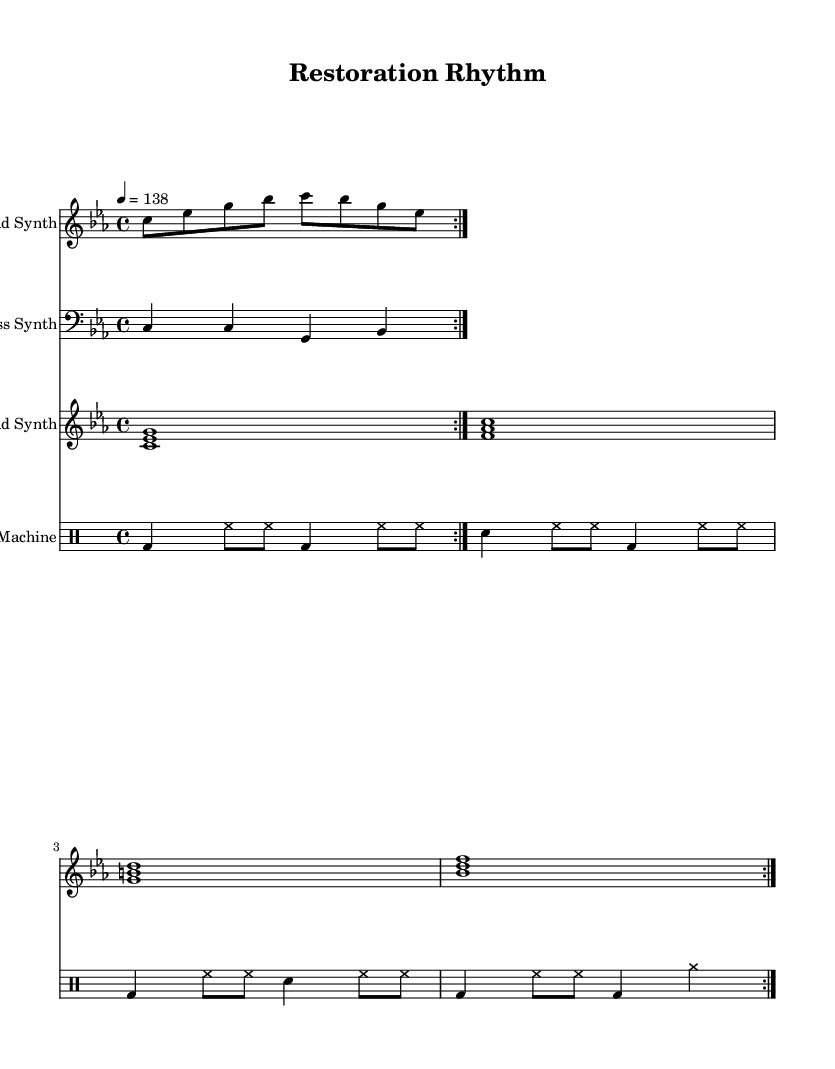What is the key signature of this music? The key signature is C minor, indicated by three flats (B♭, E♭, and A♭) at the beginning of the staff.
Answer: C minor What is the time signature of this music? The time signature is 4/4, which indicates that there are four beats in each measure and a quarter note receives one beat.
Answer: 4/4 What is the tempo marking of this music? The tempo marking is marked as 138 beats per minute, which gives the music a quick and upbeat pace.
Answer: 138 How many measures are repeated in the lead synth section? The lead synth part has a repeat indication (volta) that shows the section is played twice, thus there are two measures that are repeated.
Answer: 2 What type of drum patterns are used in this track? The drum patterns utilize a mix of bass drum, snare drum, and hi-hat patterns, which are typical in techno music to create a driving rhythm.
Answer: Bass and snare What is the duration of the pad synth chords in this piece? Each pad synth chord is played as a whole note (1) which lasts for four beats each, sustaining the harmonic richness throughout the measures.
Answer: Whole note What genre does this music belong to? This music is characterized by electronic elements, upbeat tempos, and vibrant synthesizer sounds, placing it firmly within the techno genre.
Answer: Techno 